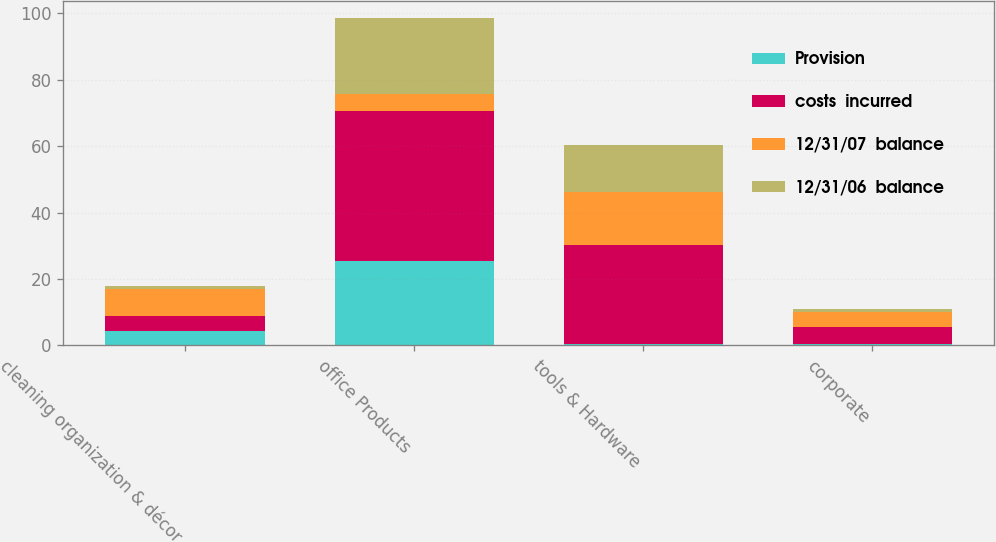Convert chart. <chart><loc_0><loc_0><loc_500><loc_500><stacked_bar_chart><ecel><fcel>cleaning organization & décor<fcel>office Products<fcel>tools & Hardware<fcel>corporate<nl><fcel>Provision<fcel>4.4<fcel>25.4<fcel>0.4<fcel>0.4<nl><fcel>costs  incurred<fcel>4.5<fcel>45<fcel>29.7<fcel>5.1<nl><fcel>12/31/07  balance<fcel>8.1<fcel>5.1<fcel>16.2<fcel>4.6<nl><fcel>12/31/06  balance<fcel>0.8<fcel>23.1<fcel>13.9<fcel>0.9<nl></chart> 